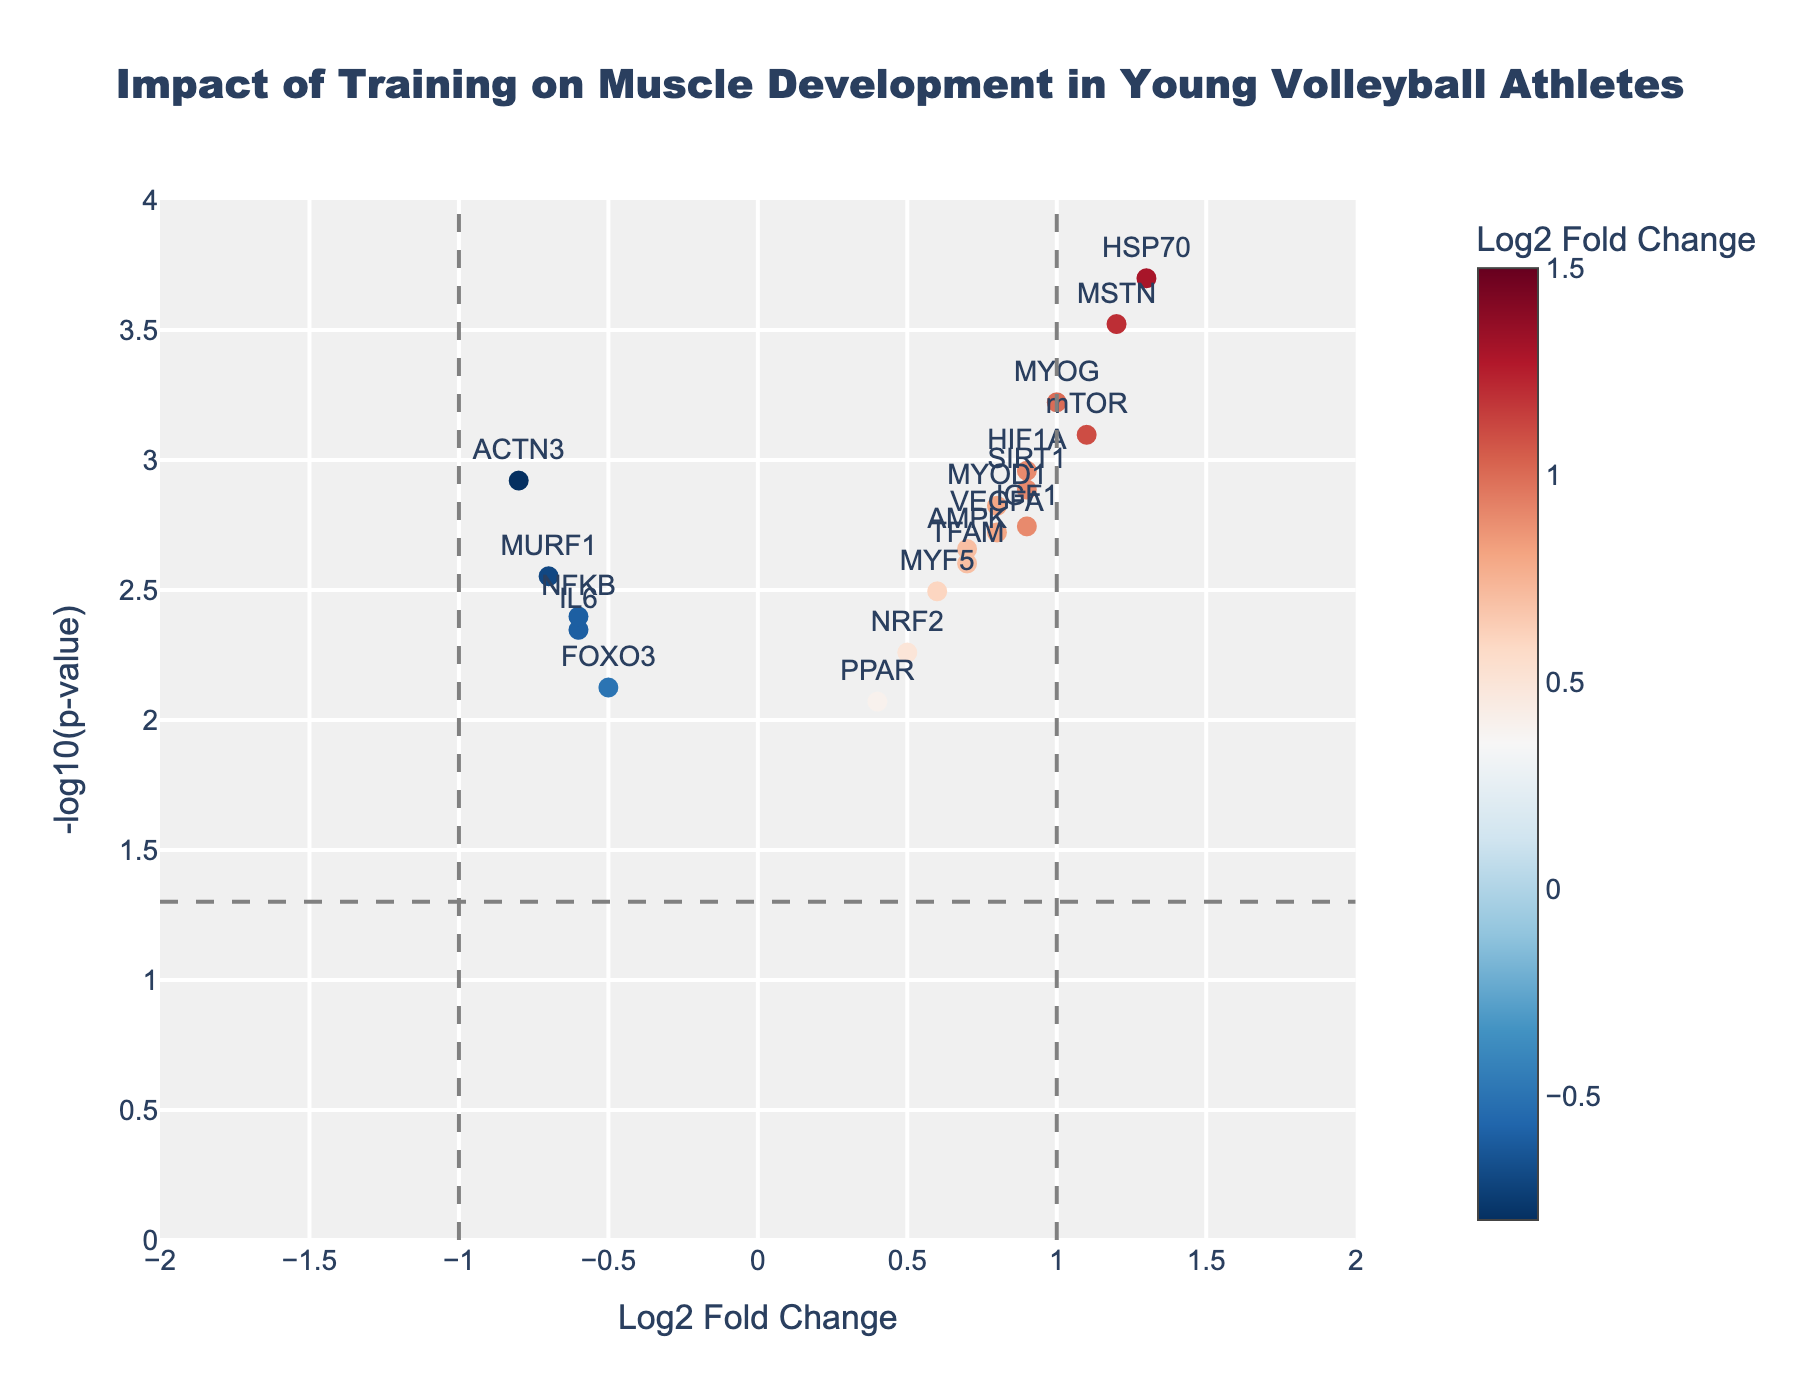What is the title of the figure? The title is typically located at the top of the figure. In this case, it reads "Impact of Training on Muscle Development in Young Volleyball Athletes".
Answer: Impact of Training on Muscle Development in Young Volleyball Athletes How many genes have a log2 fold change greater than 1? By looking at the x-axis, focus on genes located to the right of the vertical line at 1. There are four genes: MSTN, PPARGC1A, HSP70, and mTOR.
Answer: 4 Which gene has the highest -log10(p-value)? Examine the y-axis for the highest point in the plot, which represents the smallest p-value. The gene at this point is PPARGC1A.
Answer: PPARGC1A What is the range of the y-axis or -log10(p-value) values shown in the plot? The y-axis starts at 0 and goes up to 4, based on the plot's scale and grid lines.
Answer: 0 to 4 Between MYOD1 and MYOG, which gene shows up-regulation and stronger statistical significance? MYOG has a higher log2 fold change and a lower p-value compared to MYOD1, placing it higher on both the x and y axes.
Answer: MYOG List all genes with a negative log2 fold change. Focus on genes located to the left of 0 on the x-axis: ACTN3, IL6, FOXO3, MURF1, and NFKB.
Answer: ACTN3, IL6, FOXO3, MURF1, NFKB What is the log2 fold change and -log10(p-value) of the gene MSTN? Locate MSTN on the plot and read its coordinates. MSTN has a log2 fold change around 1.2 and a -log10(p-value) around 3.5.
Answer: 1.2 and 3.5 Which genes have a p-value less than 0.0005? Convert the p-value to -log10, which corresponds to values greater than 3.3. Only PPARGC1A and HSP70 meet this criterion.
Answer: PPARGC1A, HSP70 How many genes have a log2 fold change less than -0.5 but more significant than the threshold (-log10(p-value) > 1.3)? Look for genes to the left of -0.5 and above the -log10(0.05) threshold. These genes are ACTN3, MURF1, and IL6.
Answer: 3 